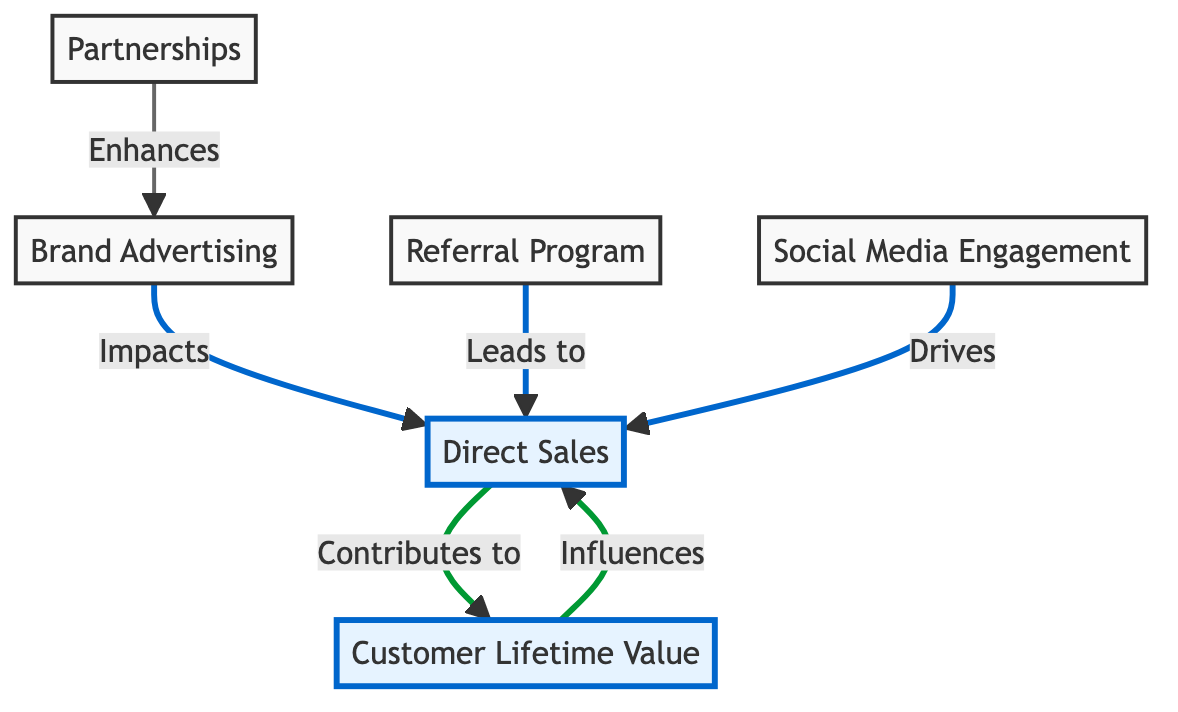What are the two main types of revenue streams depicted in the diagram? The diagram displays two main types of revenue streams: Direct Sales and Brand Advertising, as evident from the nodes represented.
Answer: Direct Sales, Brand Advertising What node is influenced by Customer Lifetime Value? The diagram shows that Customer Lifetime Value has a direct influence on the Direct Sales node, as indicated by the directed arrow labeled "Influences."
Answer: Direct Sales How many edges are there in total in the diagram? By counting the connections (edges) between the different nodes, we find that there are six edges represented in the diagram.
Answer: Six Which revenue stream directly drives Direct Sales through marketing efforts? According to the diagram, Social Media Engagement is shown as driving Direct Sales, illustrated by the directed arrow labeled "Drives."
Answer: Social Media Engagement What type of relationship exists between Partnerships and Brand Advertising? The diagram highlights that Partnerships enhance Brand Advertising, illustrated by the directed arrow labeled "Enhances" pointing from Partnerships to Brand Advertising.
Answer: Enhances What is the impact of Brand Advertising on Direct Sales? The diagram indicates that Brand Advertising impacts Direct Sales, as shown by the directed arrow labeled "Impacts" flowing from Brand Advertising to Direct Sales.
Answer: Impacts What contributes to Customer Lifetime Value from Direct Sales? The directed arrow labeled "Contributes to" in the diagram shows that Direct Sales contributes to Customer Lifetime Value.
Answer: Contributes to Which revenue stream leads to Direct Sales through referral incentives? The diagram indicates that Referral Program leads to Direct Sales, as represented by the directed arrow labeled "Leads to."
Answer: Referral Program 